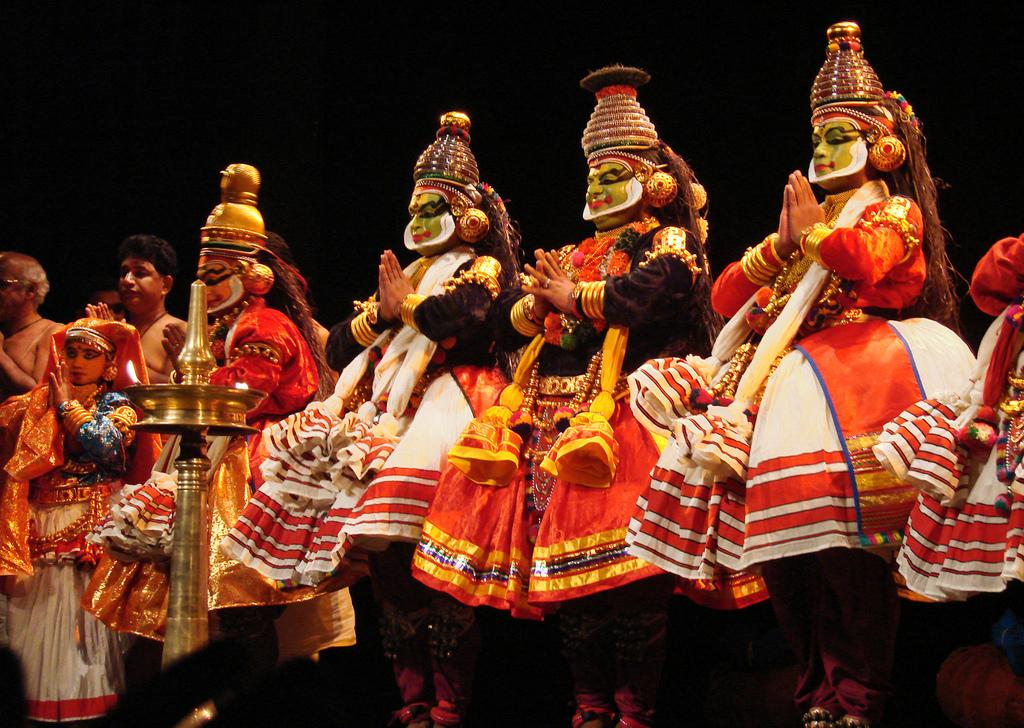What is happening in the image? There is a group of people standing in the image. Can you describe any objects in the image? Yes, there is a lamp in the image. What is the lighting like in the image? The background of the image is dark. What type of spoon is being used to lift the veil in the image? There is no spoon or veil present in the image. 